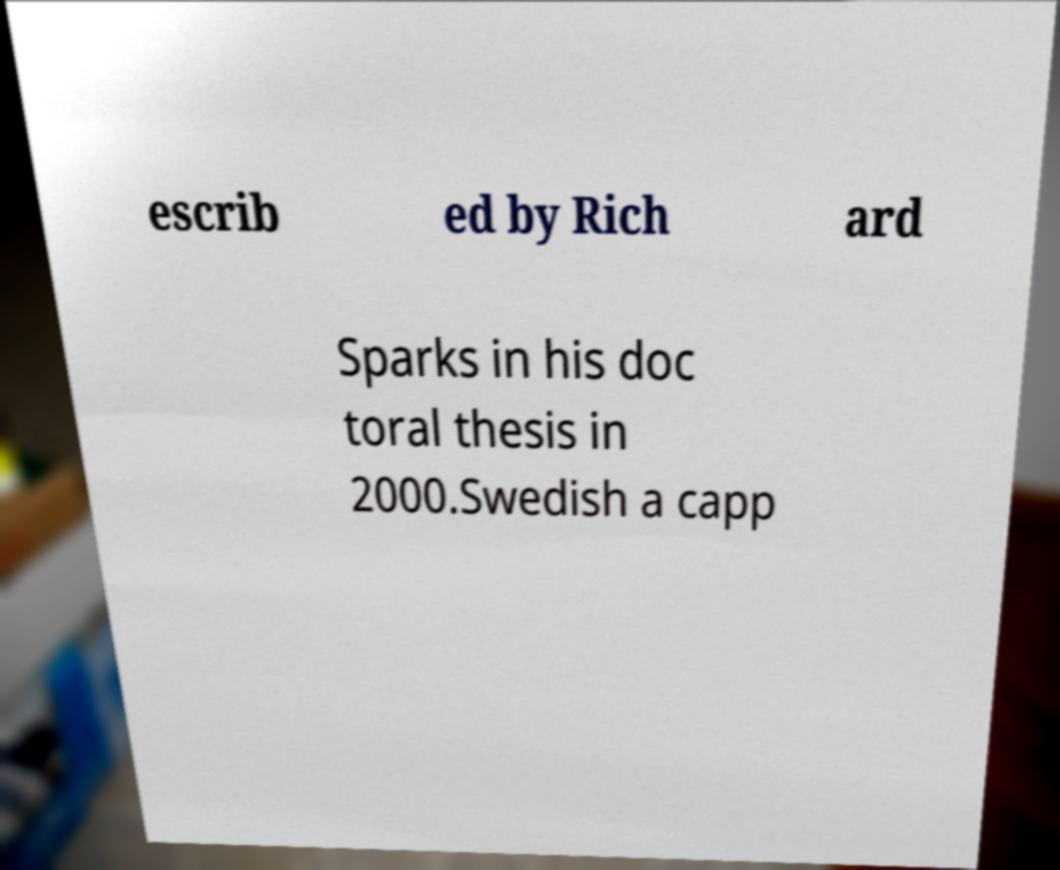Please identify and transcribe the text found in this image. escrib ed by Rich ard Sparks in his doc toral thesis in 2000.Swedish a capp 